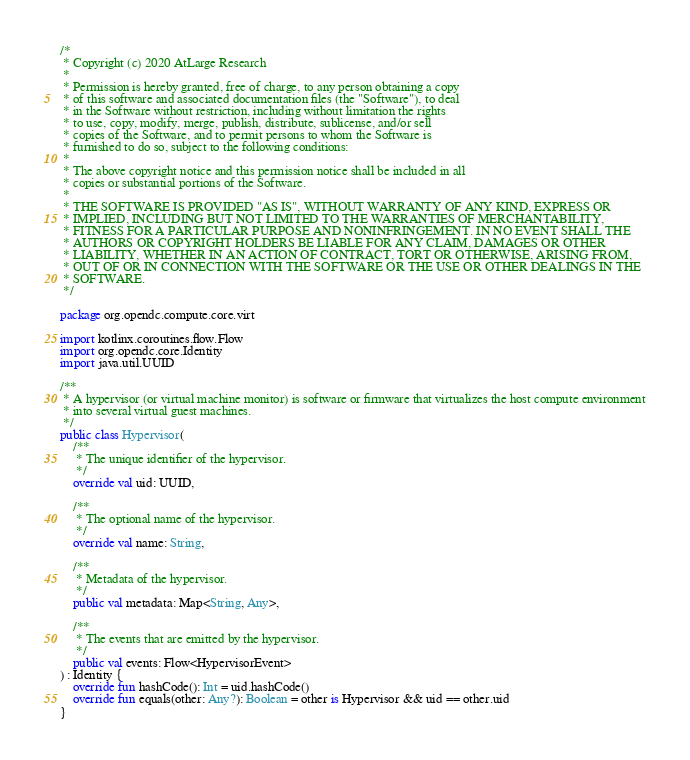Convert code to text. <code><loc_0><loc_0><loc_500><loc_500><_Kotlin_>/*
 * Copyright (c) 2020 AtLarge Research
 *
 * Permission is hereby granted, free of charge, to any person obtaining a copy
 * of this software and associated documentation files (the "Software"), to deal
 * in the Software without restriction, including without limitation the rights
 * to use, copy, modify, merge, publish, distribute, sublicense, and/or sell
 * copies of the Software, and to permit persons to whom the Software is
 * furnished to do so, subject to the following conditions:
 *
 * The above copyright notice and this permission notice shall be included in all
 * copies or substantial portions of the Software.
 *
 * THE SOFTWARE IS PROVIDED "AS IS", WITHOUT WARRANTY OF ANY KIND, EXPRESS OR
 * IMPLIED, INCLUDING BUT NOT LIMITED TO THE WARRANTIES OF MERCHANTABILITY,
 * FITNESS FOR A PARTICULAR PURPOSE AND NONINFRINGEMENT. IN NO EVENT SHALL THE
 * AUTHORS OR COPYRIGHT HOLDERS BE LIABLE FOR ANY CLAIM, DAMAGES OR OTHER
 * LIABILITY, WHETHER IN AN ACTION OF CONTRACT, TORT OR OTHERWISE, ARISING FROM,
 * OUT OF OR IN CONNECTION WITH THE SOFTWARE OR THE USE OR OTHER DEALINGS IN THE
 * SOFTWARE.
 */

package org.opendc.compute.core.virt

import kotlinx.coroutines.flow.Flow
import org.opendc.core.Identity
import java.util.UUID

/**
 * A hypervisor (or virtual machine monitor) is software or firmware that virtualizes the host compute environment
 * into several virtual guest machines.
 */
public class Hypervisor(
    /**
     * The unique identifier of the hypervisor.
     */
    override val uid: UUID,

    /**
     * The optional name of the hypervisor.
     */
    override val name: String,

    /**
     * Metadata of the hypervisor.
     */
    public val metadata: Map<String, Any>,

    /**
     * The events that are emitted by the hypervisor.
     */
    public val events: Flow<HypervisorEvent>
) : Identity {
    override fun hashCode(): Int = uid.hashCode()
    override fun equals(other: Any?): Boolean = other is Hypervisor && uid == other.uid
}
</code> 